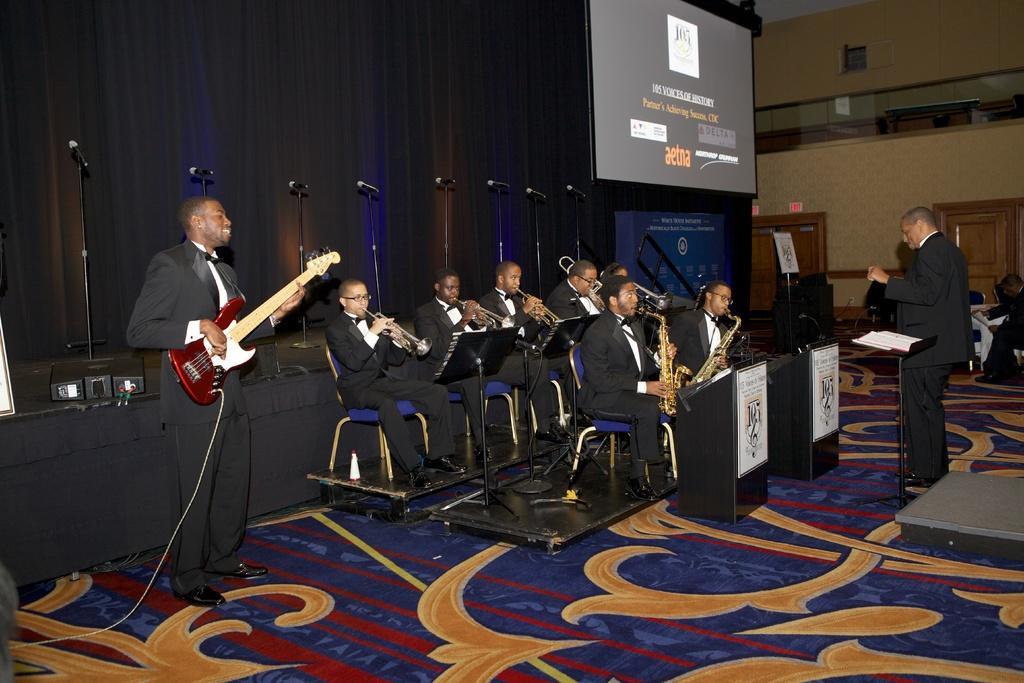Please provide a concise description of this image. In this image on the floor there is a colorful design carpet, on which there are few people sitting on chairs, holding musical instruments, in front of them there are podium and a person holding a guitar, cable cord attached to the guitar, at the top there is a curtain mike, screen on which there is a screen, a person visible in the middle, beside him there is a stand on which there is a book, there is a person sitting on chair visible in front of the door and the wall on the right side, there is a hoarding board kept on which there is a text. 